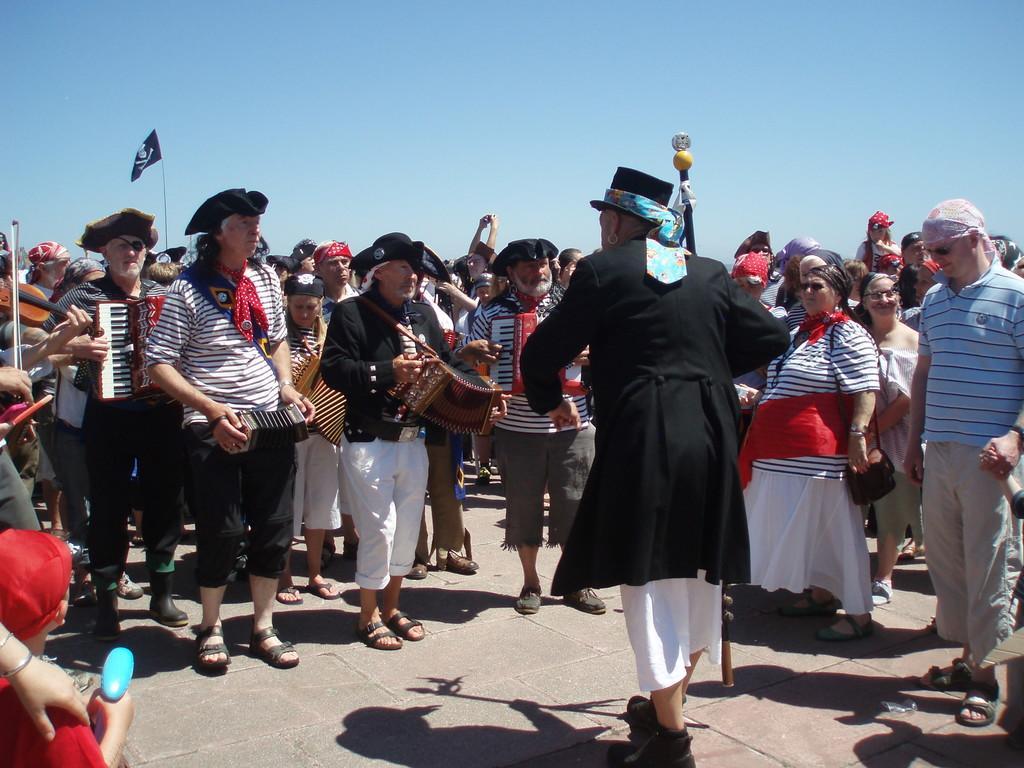Describe this image in one or two sentences. In this picture we can see a group of people where in front some people wore same black lines T-Shirt holding cardio in their hand and here the person in middle holding stick in their hand and above them we have sky and here we can see flag with pole. 